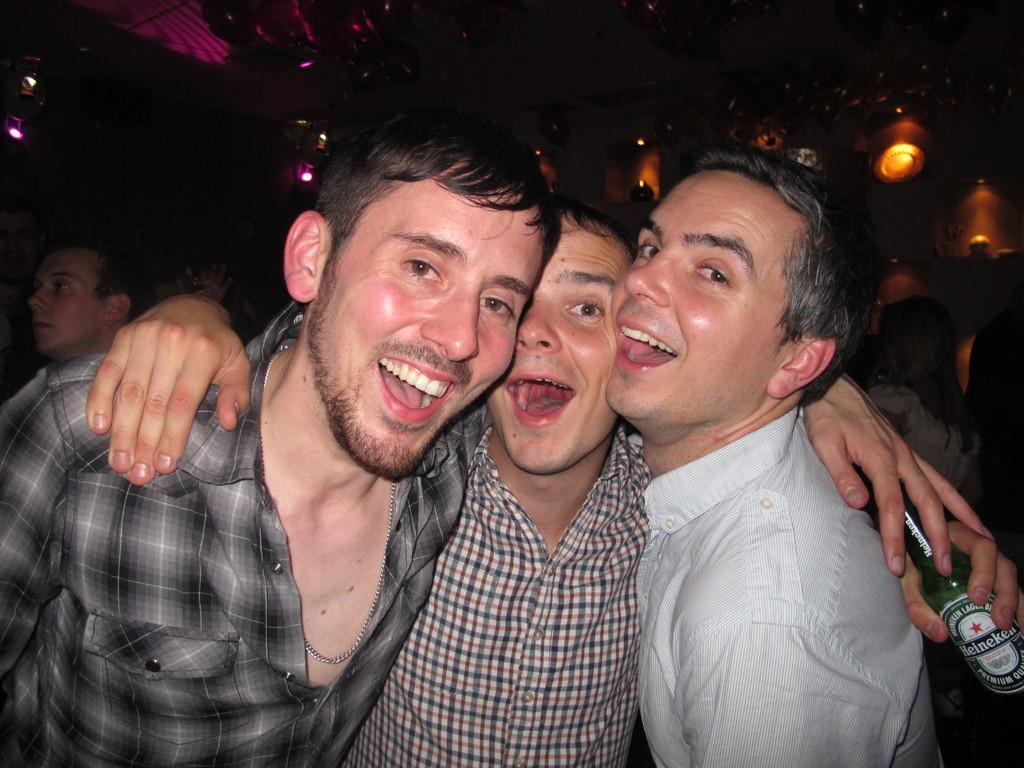How many people are in the image? There are three persons in the image. What are the three persons doing in the image? The three persons are posing for the picture. Can you describe what one of the persons is holding? One of the persons is holding a bottle. What can be seen in the background of the image? There are many people in the background of the image. What type of chicken can be seen in the image? There is no chicken present in the image. Can you describe the animal that is interacting with the persons in the image? There is no animal present in the image; it only features three persons posing for a picture. 